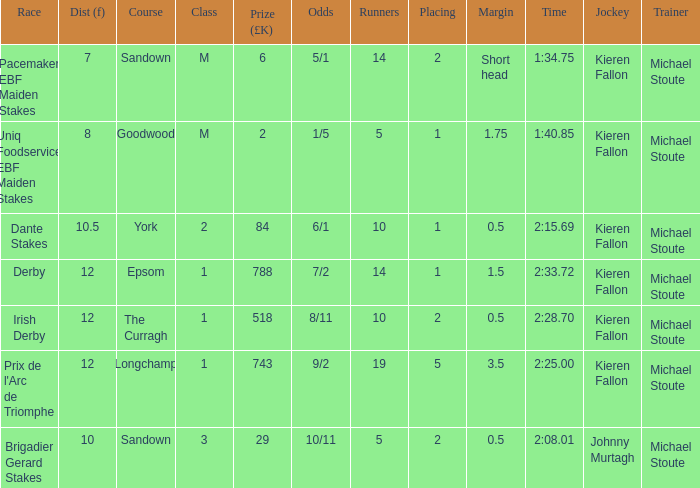Who are the participants in the longchamp race? 19.0. 